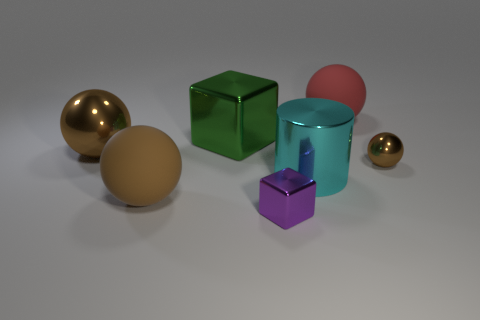Subtract all big balls. How many balls are left? 1 Subtract all purple blocks. How many brown spheres are left? 3 Add 1 big objects. How many objects exist? 8 Subtract all green blocks. How many blocks are left? 1 Subtract all blocks. How many objects are left? 5 Subtract all gray spheres. Subtract all purple cylinders. How many spheres are left? 4 Add 4 tiny yellow metal spheres. How many tiny yellow metal spheres exist? 4 Subtract 0 purple cylinders. How many objects are left? 7 Subtract all big rubber things. Subtract all small brown matte cylinders. How many objects are left? 5 Add 6 matte spheres. How many matte spheres are left? 8 